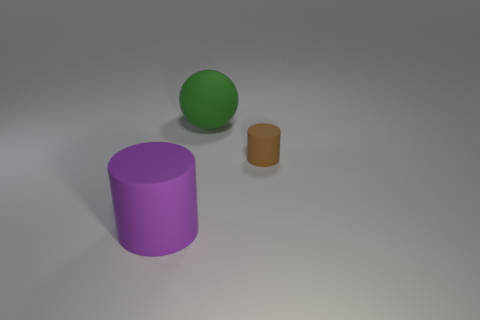What number of objects are rubber cylinders to the left of the small rubber object or small purple balls?
Your answer should be very brief. 1. What number of big purple cylinders are left of the big thing in front of the large green ball?
Offer a terse response. 0. How big is the matte cylinder behind the rubber thing in front of the rubber cylinder that is behind the large purple cylinder?
Give a very brief answer. Small. There is a big rubber object in front of the green rubber sphere; is it the same color as the tiny rubber object?
Offer a terse response. No. The brown thing that is the same shape as the purple matte thing is what size?
Keep it short and to the point. Small. How many things are big things that are behind the large purple cylinder or big matte objects that are behind the large purple cylinder?
Give a very brief answer. 1. What shape is the big rubber thing that is behind the cylinder on the left side of the small thing?
Offer a very short reply. Sphere. Is there any other thing that has the same color as the large rubber cylinder?
Ensure brevity in your answer.  No. Is there anything else that is the same size as the purple cylinder?
Make the answer very short. Yes. What number of objects are cyan things or small brown things?
Offer a very short reply. 1. 